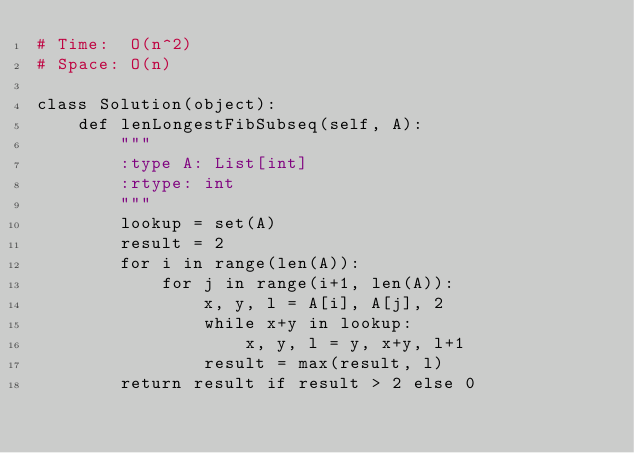<code> <loc_0><loc_0><loc_500><loc_500><_Python_># Time:  O(n^2)
# Space: O(n)

class Solution(object):
    def lenLongestFibSubseq(self, A):
        """
        :type A: List[int]
        :rtype: int
        """
        lookup = set(A)
        result = 2
        for i in range(len(A)):
            for j in range(i+1, len(A)):
                x, y, l = A[i], A[j], 2
                while x+y in lookup:
                    x, y, l = y, x+y, l+1
                result = max(result, l)
        return result if result > 2 else 0

</code> 